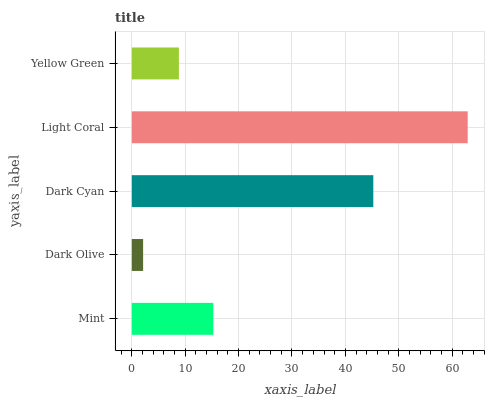Is Dark Olive the minimum?
Answer yes or no. Yes. Is Light Coral the maximum?
Answer yes or no. Yes. Is Dark Cyan the minimum?
Answer yes or no. No. Is Dark Cyan the maximum?
Answer yes or no. No. Is Dark Cyan greater than Dark Olive?
Answer yes or no. Yes. Is Dark Olive less than Dark Cyan?
Answer yes or no. Yes. Is Dark Olive greater than Dark Cyan?
Answer yes or no. No. Is Dark Cyan less than Dark Olive?
Answer yes or no. No. Is Mint the high median?
Answer yes or no. Yes. Is Mint the low median?
Answer yes or no. Yes. Is Yellow Green the high median?
Answer yes or no. No. Is Dark Olive the low median?
Answer yes or no. No. 